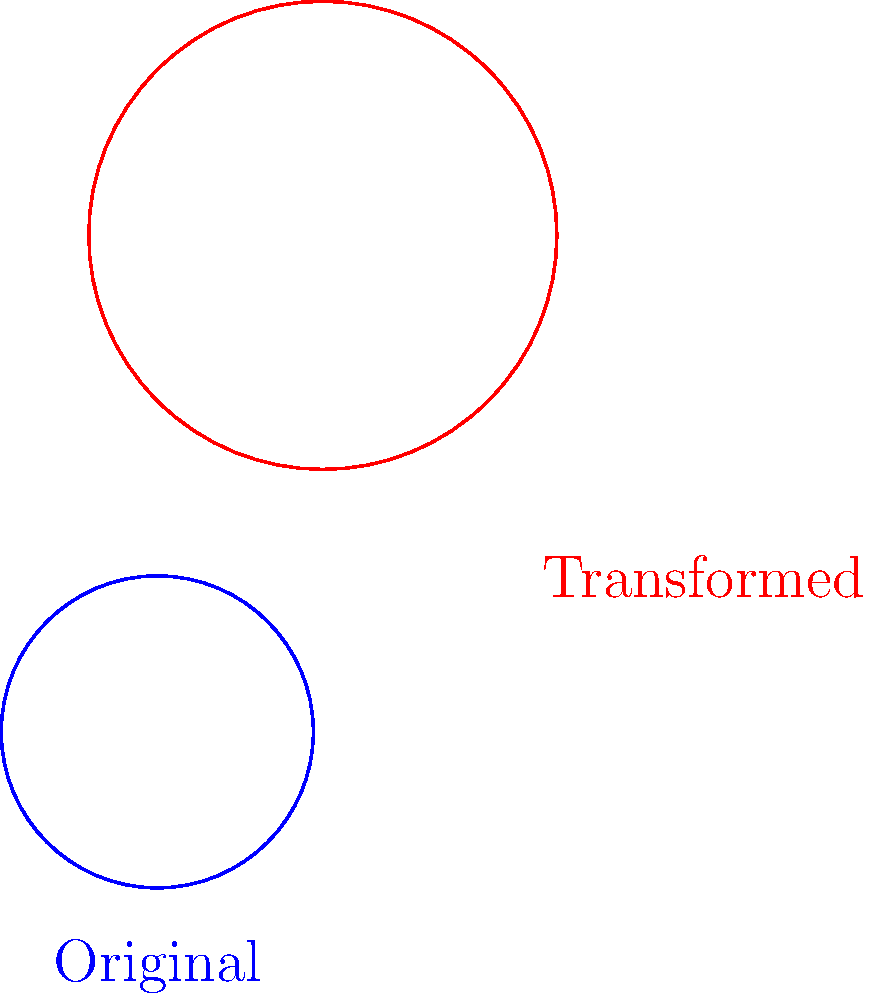As a forensic auditor investigating potential corporate logo forgery, you've encountered a suspicious version of a circular logo. The original logo is a blue circle centered at (0,0) with a radius of 1 unit. The suspicious red logo appears to be a transformed version of the original. Identify the correct sequence of transformations applied to the original logo to obtain the suspicious version. To determine the sequence of transformations, we need to analyze the changes from the original logo to the transformed one:

1. Position: The center of the transformed logo has moved. This indicates a translation (shift).
2. Size: The transformed logo appears larger than the original. This suggests a scaling operation.
3. Orientation: The transformed logo is rotated compared to the original. This implies a rotation.

To identify the correct sequence, we need to consider that transformations are typically applied from right to left in mathematics. Let's break down the process:

1. Shift: The logo's center has moved approximately 2 units right and 1 unit up. This is likely the first transformation applied.
2. Rotation: The logo appears to be rotated about 45 degrees counterclockwise. This would be applied after the shift.
3. Scaling: The logo is about 1.5 times larger than the original. This is likely the last transformation applied.

Therefore, the sequence of transformations, from first to last, would be:

1. Shift by (2,1)
2. Rotate by 45 degrees
3. Scale by a factor of 1.5

In mathematical notation, this can be expressed as:

$$ T(x,y) = S_{1.5} \circ R_{45°} \circ T_{(2,1)}(x,y) $$

Where $T_{(2,1)}$ represents the translation, $R_{45°}$ the rotation, and $S_{1.5}$ the scaling.
Answer: Shift(2,1) → Rotate(45°) → Scale(1.5) 